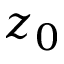<formula> <loc_0><loc_0><loc_500><loc_500>z _ { 0 }</formula> 